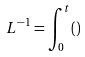<formula> <loc_0><loc_0><loc_500><loc_500>L ^ { - 1 } = \int _ { 0 } ^ { t } ( )</formula> 